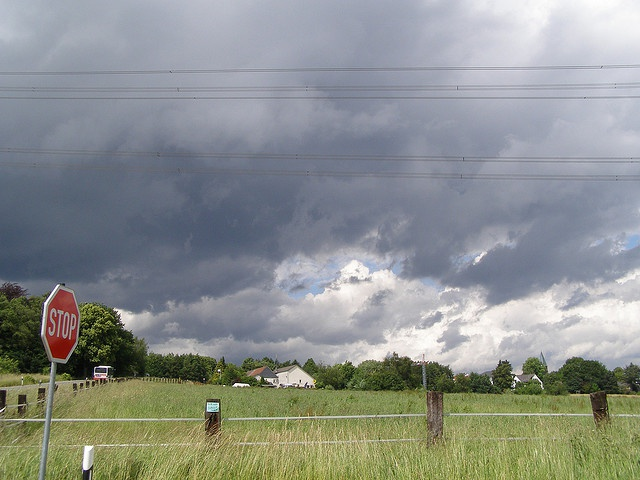Describe the objects in this image and their specific colors. I can see stop sign in lightgray, brown, maroon, and darkgray tones, bus in lightgray, black, gray, and darkgray tones, and car in lightgray, black, darkgray, olive, and gray tones in this image. 